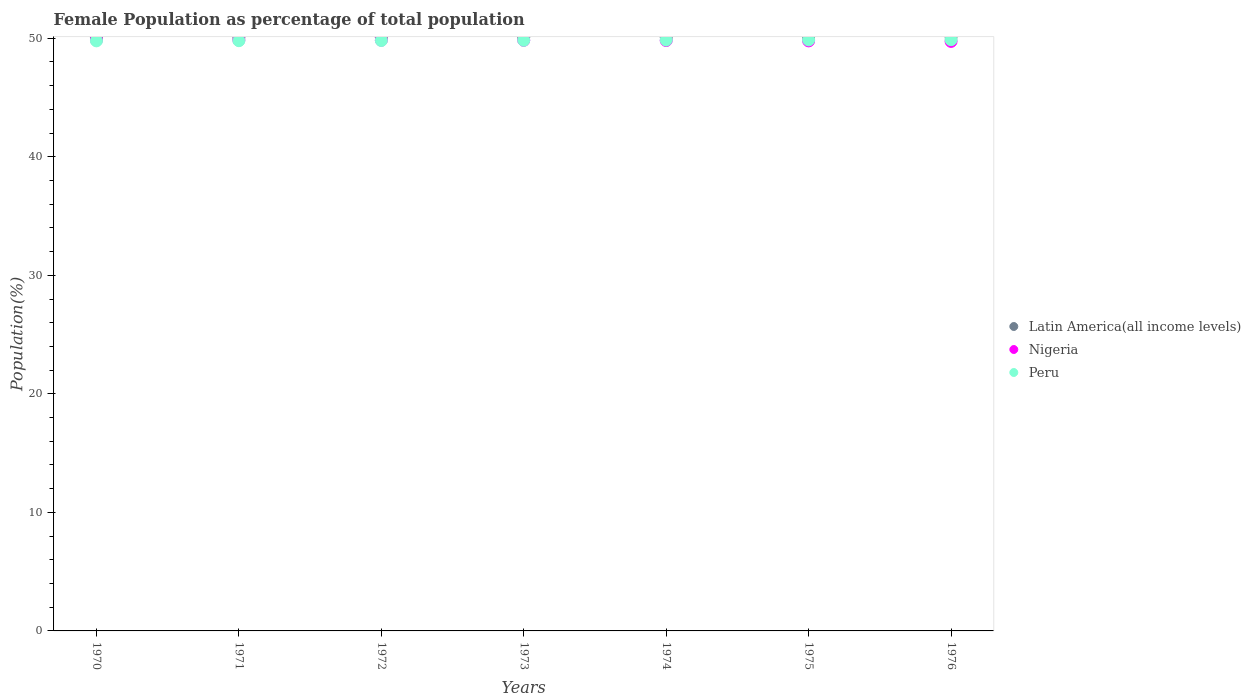How many different coloured dotlines are there?
Your response must be concise. 3. What is the female population in in Peru in 1972?
Make the answer very short. 49.81. Across all years, what is the maximum female population in in Nigeria?
Make the answer very short. 49.86. Across all years, what is the minimum female population in in Nigeria?
Your response must be concise. 49.73. In which year was the female population in in Peru maximum?
Your answer should be compact. 1976. In which year was the female population in in Nigeria minimum?
Offer a very short reply. 1976. What is the total female population in in Latin America(all income levels) in the graph?
Give a very brief answer. 350.6. What is the difference between the female population in in Peru in 1970 and that in 1973?
Your answer should be compact. -0.05. What is the difference between the female population in in Latin America(all income levels) in 1975 and the female population in in Peru in 1976?
Offer a terse response. 0.23. What is the average female population in in Peru per year?
Ensure brevity in your answer.  49.83. In the year 1970, what is the difference between the female population in in Nigeria and female population in in Peru?
Provide a short and direct response. 0.08. What is the ratio of the female population in in Nigeria in 1974 to that in 1976?
Offer a very short reply. 1. Is the difference between the female population in in Nigeria in 1971 and 1975 greater than the difference between the female population in in Peru in 1971 and 1975?
Your response must be concise. Yes. What is the difference between the highest and the second highest female population in in Peru?
Give a very brief answer. 0.02. What is the difference between the highest and the lowest female population in in Latin America(all income levels)?
Offer a very short reply. 0.06. In how many years, is the female population in in Latin America(all income levels) greater than the average female population in in Latin America(all income levels) taken over all years?
Give a very brief answer. 3. Is the sum of the female population in in Nigeria in 1970 and 1973 greater than the maximum female population in in Peru across all years?
Make the answer very short. Yes. Is it the case that in every year, the sum of the female population in in Latin America(all income levels) and female population in in Nigeria  is greater than the female population in in Peru?
Provide a succinct answer. Yes. Does the female population in in Latin America(all income levels) monotonically increase over the years?
Ensure brevity in your answer.  Yes. Is the female population in in Peru strictly less than the female population in in Nigeria over the years?
Give a very brief answer. No. Are the values on the major ticks of Y-axis written in scientific E-notation?
Provide a succinct answer. No. Does the graph contain any zero values?
Your answer should be compact. No. Where does the legend appear in the graph?
Ensure brevity in your answer.  Center right. What is the title of the graph?
Your response must be concise. Female Population as percentage of total population. What is the label or title of the X-axis?
Your response must be concise. Years. What is the label or title of the Y-axis?
Your answer should be very brief. Population(%). What is the Population(%) in Latin America(all income levels) in 1970?
Your answer should be very brief. 50.06. What is the Population(%) in Nigeria in 1970?
Your answer should be very brief. 49.86. What is the Population(%) in Peru in 1970?
Your answer should be very brief. 49.78. What is the Population(%) of Latin America(all income levels) in 1971?
Offer a terse response. 50.06. What is the Population(%) in Nigeria in 1971?
Provide a short and direct response. 49.85. What is the Population(%) in Peru in 1971?
Your answer should be very brief. 49.79. What is the Population(%) of Latin America(all income levels) in 1972?
Ensure brevity in your answer.  50.07. What is the Population(%) in Nigeria in 1972?
Offer a very short reply. 49.84. What is the Population(%) in Peru in 1972?
Make the answer very short. 49.81. What is the Population(%) in Latin America(all income levels) in 1973?
Your answer should be very brief. 50.08. What is the Population(%) of Nigeria in 1973?
Ensure brevity in your answer.  49.83. What is the Population(%) of Peru in 1973?
Ensure brevity in your answer.  49.83. What is the Population(%) of Latin America(all income levels) in 1974?
Keep it short and to the point. 50.09. What is the Population(%) of Nigeria in 1974?
Provide a short and direct response. 49.81. What is the Population(%) in Peru in 1974?
Offer a very short reply. 49.84. What is the Population(%) in Latin America(all income levels) in 1975?
Your answer should be compact. 50.11. What is the Population(%) of Nigeria in 1975?
Provide a succinct answer. 49.78. What is the Population(%) in Peru in 1975?
Offer a very short reply. 49.86. What is the Population(%) of Latin America(all income levels) in 1976?
Offer a very short reply. 50.12. What is the Population(%) in Nigeria in 1976?
Give a very brief answer. 49.73. What is the Population(%) of Peru in 1976?
Give a very brief answer. 49.88. Across all years, what is the maximum Population(%) of Latin America(all income levels)?
Your response must be concise. 50.12. Across all years, what is the maximum Population(%) in Nigeria?
Keep it short and to the point. 49.86. Across all years, what is the maximum Population(%) in Peru?
Your answer should be compact. 49.88. Across all years, what is the minimum Population(%) in Latin America(all income levels)?
Your response must be concise. 50.06. Across all years, what is the minimum Population(%) of Nigeria?
Your answer should be compact. 49.73. Across all years, what is the minimum Population(%) in Peru?
Your response must be concise. 49.78. What is the total Population(%) of Latin America(all income levels) in the graph?
Provide a short and direct response. 350.6. What is the total Population(%) of Nigeria in the graph?
Offer a very short reply. 348.69. What is the total Population(%) of Peru in the graph?
Offer a very short reply. 348.79. What is the difference between the Population(%) of Latin America(all income levels) in 1970 and that in 1971?
Your response must be concise. -0.01. What is the difference between the Population(%) in Nigeria in 1970 and that in 1971?
Offer a very short reply. 0.01. What is the difference between the Population(%) in Peru in 1970 and that in 1971?
Your answer should be very brief. -0.01. What is the difference between the Population(%) in Latin America(all income levels) in 1970 and that in 1972?
Your response must be concise. -0.02. What is the difference between the Population(%) in Nigeria in 1970 and that in 1972?
Make the answer very short. 0.02. What is the difference between the Population(%) of Peru in 1970 and that in 1972?
Make the answer very short. -0.03. What is the difference between the Population(%) of Latin America(all income levels) in 1970 and that in 1973?
Your answer should be compact. -0.03. What is the difference between the Population(%) in Nigeria in 1970 and that in 1973?
Your response must be concise. 0.03. What is the difference between the Population(%) of Peru in 1970 and that in 1973?
Your response must be concise. -0.05. What is the difference between the Population(%) of Latin America(all income levels) in 1970 and that in 1974?
Offer a terse response. -0.04. What is the difference between the Population(%) in Nigeria in 1970 and that in 1974?
Give a very brief answer. 0.05. What is the difference between the Population(%) in Peru in 1970 and that in 1974?
Offer a very short reply. -0.06. What is the difference between the Population(%) in Latin America(all income levels) in 1970 and that in 1975?
Your answer should be very brief. -0.05. What is the difference between the Population(%) in Nigeria in 1970 and that in 1975?
Provide a short and direct response. 0.08. What is the difference between the Population(%) of Peru in 1970 and that in 1975?
Your answer should be compact. -0.08. What is the difference between the Population(%) of Latin America(all income levels) in 1970 and that in 1976?
Offer a terse response. -0.06. What is the difference between the Population(%) in Nigeria in 1970 and that in 1976?
Your answer should be very brief. 0.13. What is the difference between the Population(%) of Peru in 1970 and that in 1976?
Provide a short and direct response. -0.1. What is the difference between the Population(%) of Latin America(all income levels) in 1971 and that in 1972?
Offer a very short reply. -0.01. What is the difference between the Population(%) in Nigeria in 1971 and that in 1972?
Offer a terse response. 0.01. What is the difference between the Population(%) in Peru in 1971 and that in 1972?
Your response must be concise. -0.02. What is the difference between the Population(%) of Latin America(all income levels) in 1971 and that in 1973?
Give a very brief answer. -0.02. What is the difference between the Population(%) of Nigeria in 1971 and that in 1973?
Offer a terse response. 0.02. What is the difference between the Population(%) in Peru in 1971 and that in 1973?
Provide a short and direct response. -0.03. What is the difference between the Population(%) of Latin America(all income levels) in 1971 and that in 1974?
Provide a short and direct response. -0.03. What is the difference between the Population(%) in Nigeria in 1971 and that in 1974?
Your answer should be very brief. 0.04. What is the difference between the Population(%) in Peru in 1971 and that in 1974?
Give a very brief answer. -0.05. What is the difference between the Population(%) in Latin America(all income levels) in 1971 and that in 1975?
Provide a succinct answer. -0.04. What is the difference between the Population(%) in Nigeria in 1971 and that in 1975?
Provide a succinct answer. 0.07. What is the difference between the Population(%) of Peru in 1971 and that in 1975?
Your response must be concise. -0.07. What is the difference between the Population(%) in Latin America(all income levels) in 1971 and that in 1976?
Offer a terse response. -0.06. What is the difference between the Population(%) in Nigeria in 1971 and that in 1976?
Your answer should be very brief. 0.11. What is the difference between the Population(%) in Peru in 1971 and that in 1976?
Ensure brevity in your answer.  -0.08. What is the difference between the Population(%) of Latin America(all income levels) in 1972 and that in 1973?
Make the answer very short. -0.01. What is the difference between the Population(%) of Nigeria in 1972 and that in 1973?
Keep it short and to the point. 0.01. What is the difference between the Population(%) of Peru in 1972 and that in 1973?
Keep it short and to the point. -0.02. What is the difference between the Population(%) of Latin America(all income levels) in 1972 and that in 1974?
Make the answer very short. -0.02. What is the difference between the Population(%) of Nigeria in 1972 and that in 1974?
Keep it short and to the point. 0.03. What is the difference between the Population(%) in Peru in 1972 and that in 1974?
Ensure brevity in your answer.  -0.03. What is the difference between the Population(%) in Latin America(all income levels) in 1972 and that in 1975?
Provide a short and direct response. -0.03. What is the difference between the Population(%) of Nigeria in 1972 and that in 1975?
Offer a terse response. 0.06. What is the difference between the Population(%) in Peru in 1972 and that in 1975?
Give a very brief answer. -0.05. What is the difference between the Population(%) in Latin America(all income levels) in 1972 and that in 1976?
Offer a very short reply. -0.05. What is the difference between the Population(%) in Nigeria in 1972 and that in 1976?
Your answer should be very brief. 0.1. What is the difference between the Population(%) of Peru in 1972 and that in 1976?
Make the answer very short. -0.07. What is the difference between the Population(%) in Latin America(all income levels) in 1973 and that in 1974?
Offer a terse response. -0.01. What is the difference between the Population(%) of Nigeria in 1973 and that in 1974?
Your answer should be compact. 0.02. What is the difference between the Population(%) of Peru in 1973 and that in 1974?
Provide a short and direct response. -0.02. What is the difference between the Population(%) in Latin America(all income levels) in 1973 and that in 1975?
Your answer should be compact. -0.02. What is the difference between the Population(%) in Nigeria in 1973 and that in 1975?
Your response must be concise. 0.05. What is the difference between the Population(%) in Peru in 1973 and that in 1975?
Provide a short and direct response. -0.03. What is the difference between the Population(%) of Latin America(all income levels) in 1973 and that in 1976?
Provide a succinct answer. -0.04. What is the difference between the Population(%) in Nigeria in 1973 and that in 1976?
Make the answer very short. 0.09. What is the difference between the Population(%) in Peru in 1973 and that in 1976?
Offer a terse response. -0.05. What is the difference between the Population(%) in Latin America(all income levels) in 1974 and that in 1975?
Keep it short and to the point. -0.01. What is the difference between the Population(%) of Nigeria in 1974 and that in 1975?
Your response must be concise. 0.03. What is the difference between the Population(%) of Peru in 1974 and that in 1975?
Ensure brevity in your answer.  -0.02. What is the difference between the Population(%) in Latin America(all income levels) in 1974 and that in 1976?
Provide a succinct answer. -0.03. What is the difference between the Population(%) of Nigeria in 1974 and that in 1976?
Keep it short and to the point. 0.07. What is the difference between the Population(%) in Peru in 1974 and that in 1976?
Provide a succinct answer. -0.03. What is the difference between the Population(%) in Latin America(all income levels) in 1975 and that in 1976?
Your answer should be very brief. -0.01. What is the difference between the Population(%) in Nigeria in 1975 and that in 1976?
Provide a succinct answer. 0.04. What is the difference between the Population(%) in Peru in 1975 and that in 1976?
Your answer should be very brief. -0.02. What is the difference between the Population(%) of Latin America(all income levels) in 1970 and the Population(%) of Nigeria in 1971?
Your response must be concise. 0.21. What is the difference between the Population(%) in Latin America(all income levels) in 1970 and the Population(%) in Peru in 1971?
Ensure brevity in your answer.  0.26. What is the difference between the Population(%) in Nigeria in 1970 and the Population(%) in Peru in 1971?
Give a very brief answer. 0.07. What is the difference between the Population(%) in Latin America(all income levels) in 1970 and the Population(%) in Nigeria in 1972?
Provide a short and direct response. 0.22. What is the difference between the Population(%) in Latin America(all income levels) in 1970 and the Population(%) in Peru in 1972?
Ensure brevity in your answer.  0.25. What is the difference between the Population(%) in Nigeria in 1970 and the Population(%) in Peru in 1972?
Your answer should be compact. 0.05. What is the difference between the Population(%) in Latin America(all income levels) in 1970 and the Population(%) in Nigeria in 1973?
Offer a very short reply. 0.23. What is the difference between the Population(%) in Latin America(all income levels) in 1970 and the Population(%) in Peru in 1973?
Provide a short and direct response. 0.23. What is the difference between the Population(%) of Nigeria in 1970 and the Population(%) of Peru in 1973?
Provide a succinct answer. 0.04. What is the difference between the Population(%) in Latin America(all income levels) in 1970 and the Population(%) in Nigeria in 1974?
Offer a terse response. 0.25. What is the difference between the Population(%) in Latin America(all income levels) in 1970 and the Population(%) in Peru in 1974?
Offer a very short reply. 0.21. What is the difference between the Population(%) in Nigeria in 1970 and the Population(%) in Peru in 1974?
Make the answer very short. 0.02. What is the difference between the Population(%) in Latin America(all income levels) in 1970 and the Population(%) in Nigeria in 1975?
Give a very brief answer. 0.28. What is the difference between the Population(%) of Latin America(all income levels) in 1970 and the Population(%) of Peru in 1975?
Make the answer very short. 0.2. What is the difference between the Population(%) in Latin America(all income levels) in 1970 and the Population(%) in Nigeria in 1976?
Ensure brevity in your answer.  0.32. What is the difference between the Population(%) in Latin America(all income levels) in 1970 and the Population(%) in Peru in 1976?
Keep it short and to the point. 0.18. What is the difference between the Population(%) in Nigeria in 1970 and the Population(%) in Peru in 1976?
Keep it short and to the point. -0.02. What is the difference between the Population(%) of Latin America(all income levels) in 1971 and the Population(%) of Nigeria in 1972?
Offer a very short reply. 0.23. What is the difference between the Population(%) in Latin America(all income levels) in 1971 and the Population(%) in Peru in 1972?
Ensure brevity in your answer.  0.26. What is the difference between the Population(%) in Nigeria in 1971 and the Population(%) in Peru in 1972?
Ensure brevity in your answer.  0.04. What is the difference between the Population(%) of Latin America(all income levels) in 1971 and the Population(%) of Nigeria in 1973?
Ensure brevity in your answer.  0.24. What is the difference between the Population(%) in Latin America(all income levels) in 1971 and the Population(%) in Peru in 1973?
Give a very brief answer. 0.24. What is the difference between the Population(%) of Nigeria in 1971 and the Population(%) of Peru in 1973?
Offer a very short reply. 0.02. What is the difference between the Population(%) in Latin America(all income levels) in 1971 and the Population(%) in Nigeria in 1974?
Your response must be concise. 0.26. What is the difference between the Population(%) of Latin America(all income levels) in 1971 and the Population(%) of Peru in 1974?
Give a very brief answer. 0.22. What is the difference between the Population(%) of Nigeria in 1971 and the Population(%) of Peru in 1974?
Give a very brief answer. 0.01. What is the difference between the Population(%) of Latin America(all income levels) in 1971 and the Population(%) of Nigeria in 1975?
Give a very brief answer. 0.29. What is the difference between the Population(%) of Latin America(all income levels) in 1971 and the Population(%) of Peru in 1975?
Keep it short and to the point. 0.2. What is the difference between the Population(%) of Nigeria in 1971 and the Population(%) of Peru in 1975?
Keep it short and to the point. -0.01. What is the difference between the Population(%) in Latin America(all income levels) in 1971 and the Population(%) in Nigeria in 1976?
Keep it short and to the point. 0.33. What is the difference between the Population(%) in Latin America(all income levels) in 1971 and the Population(%) in Peru in 1976?
Give a very brief answer. 0.19. What is the difference between the Population(%) in Nigeria in 1971 and the Population(%) in Peru in 1976?
Keep it short and to the point. -0.03. What is the difference between the Population(%) of Latin America(all income levels) in 1972 and the Population(%) of Nigeria in 1973?
Provide a succinct answer. 0.25. What is the difference between the Population(%) of Latin America(all income levels) in 1972 and the Population(%) of Peru in 1973?
Offer a terse response. 0.25. What is the difference between the Population(%) in Nigeria in 1972 and the Population(%) in Peru in 1973?
Your answer should be compact. 0.01. What is the difference between the Population(%) in Latin America(all income levels) in 1972 and the Population(%) in Nigeria in 1974?
Your answer should be compact. 0.27. What is the difference between the Population(%) in Latin America(all income levels) in 1972 and the Population(%) in Peru in 1974?
Make the answer very short. 0.23. What is the difference between the Population(%) of Nigeria in 1972 and the Population(%) of Peru in 1974?
Provide a succinct answer. -0. What is the difference between the Population(%) in Latin America(all income levels) in 1972 and the Population(%) in Nigeria in 1975?
Your response must be concise. 0.3. What is the difference between the Population(%) in Latin America(all income levels) in 1972 and the Population(%) in Peru in 1975?
Provide a short and direct response. 0.21. What is the difference between the Population(%) in Nigeria in 1972 and the Population(%) in Peru in 1975?
Your answer should be compact. -0.02. What is the difference between the Population(%) in Latin America(all income levels) in 1972 and the Population(%) in Nigeria in 1976?
Keep it short and to the point. 0.34. What is the difference between the Population(%) of Latin America(all income levels) in 1972 and the Population(%) of Peru in 1976?
Give a very brief answer. 0.2. What is the difference between the Population(%) of Nigeria in 1972 and the Population(%) of Peru in 1976?
Keep it short and to the point. -0.04. What is the difference between the Population(%) in Latin America(all income levels) in 1973 and the Population(%) in Nigeria in 1974?
Make the answer very short. 0.28. What is the difference between the Population(%) of Latin America(all income levels) in 1973 and the Population(%) of Peru in 1974?
Your answer should be very brief. 0.24. What is the difference between the Population(%) in Nigeria in 1973 and the Population(%) in Peru in 1974?
Provide a short and direct response. -0.02. What is the difference between the Population(%) of Latin America(all income levels) in 1973 and the Population(%) of Nigeria in 1975?
Provide a short and direct response. 0.31. What is the difference between the Population(%) in Latin America(all income levels) in 1973 and the Population(%) in Peru in 1975?
Your response must be concise. 0.22. What is the difference between the Population(%) of Nigeria in 1973 and the Population(%) of Peru in 1975?
Provide a succinct answer. -0.03. What is the difference between the Population(%) in Latin America(all income levels) in 1973 and the Population(%) in Nigeria in 1976?
Keep it short and to the point. 0.35. What is the difference between the Population(%) of Latin America(all income levels) in 1973 and the Population(%) of Peru in 1976?
Provide a succinct answer. 0.21. What is the difference between the Population(%) in Nigeria in 1973 and the Population(%) in Peru in 1976?
Ensure brevity in your answer.  -0.05. What is the difference between the Population(%) in Latin America(all income levels) in 1974 and the Population(%) in Nigeria in 1975?
Your answer should be very brief. 0.32. What is the difference between the Population(%) in Latin America(all income levels) in 1974 and the Population(%) in Peru in 1975?
Ensure brevity in your answer.  0.23. What is the difference between the Population(%) in Nigeria in 1974 and the Population(%) in Peru in 1975?
Give a very brief answer. -0.05. What is the difference between the Population(%) in Latin America(all income levels) in 1974 and the Population(%) in Nigeria in 1976?
Provide a short and direct response. 0.36. What is the difference between the Population(%) of Latin America(all income levels) in 1974 and the Population(%) of Peru in 1976?
Offer a terse response. 0.22. What is the difference between the Population(%) in Nigeria in 1974 and the Population(%) in Peru in 1976?
Provide a succinct answer. -0.07. What is the difference between the Population(%) in Latin America(all income levels) in 1975 and the Population(%) in Nigeria in 1976?
Give a very brief answer. 0.37. What is the difference between the Population(%) in Latin America(all income levels) in 1975 and the Population(%) in Peru in 1976?
Offer a very short reply. 0.23. What is the difference between the Population(%) of Nigeria in 1975 and the Population(%) of Peru in 1976?
Ensure brevity in your answer.  -0.1. What is the average Population(%) in Latin America(all income levels) per year?
Provide a succinct answer. 50.09. What is the average Population(%) in Nigeria per year?
Your response must be concise. 49.81. What is the average Population(%) of Peru per year?
Give a very brief answer. 49.83. In the year 1970, what is the difference between the Population(%) of Latin America(all income levels) and Population(%) of Nigeria?
Your answer should be compact. 0.2. In the year 1970, what is the difference between the Population(%) of Latin America(all income levels) and Population(%) of Peru?
Your answer should be very brief. 0.28. In the year 1970, what is the difference between the Population(%) in Nigeria and Population(%) in Peru?
Give a very brief answer. 0.08. In the year 1971, what is the difference between the Population(%) of Latin America(all income levels) and Population(%) of Nigeria?
Your answer should be compact. 0.21. In the year 1971, what is the difference between the Population(%) in Latin America(all income levels) and Population(%) in Peru?
Provide a succinct answer. 0.27. In the year 1971, what is the difference between the Population(%) in Nigeria and Population(%) in Peru?
Your answer should be very brief. 0.06. In the year 1972, what is the difference between the Population(%) in Latin America(all income levels) and Population(%) in Nigeria?
Offer a very short reply. 0.23. In the year 1972, what is the difference between the Population(%) in Latin America(all income levels) and Population(%) in Peru?
Your answer should be very brief. 0.26. In the year 1972, what is the difference between the Population(%) in Nigeria and Population(%) in Peru?
Provide a succinct answer. 0.03. In the year 1973, what is the difference between the Population(%) of Latin America(all income levels) and Population(%) of Nigeria?
Keep it short and to the point. 0.26. In the year 1973, what is the difference between the Population(%) of Latin America(all income levels) and Population(%) of Peru?
Your answer should be very brief. 0.26. In the year 1974, what is the difference between the Population(%) of Latin America(all income levels) and Population(%) of Nigeria?
Make the answer very short. 0.29. In the year 1974, what is the difference between the Population(%) in Latin America(all income levels) and Population(%) in Peru?
Offer a very short reply. 0.25. In the year 1974, what is the difference between the Population(%) in Nigeria and Population(%) in Peru?
Ensure brevity in your answer.  -0.04. In the year 1975, what is the difference between the Population(%) of Latin America(all income levels) and Population(%) of Nigeria?
Provide a short and direct response. 0.33. In the year 1975, what is the difference between the Population(%) of Latin America(all income levels) and Population(%) of Peru?
Offer a terse response. 0.25. In the year 1975, what is the difference between the Population(%) in Nigeria and Population(%) in Peru?
Your response must be concise. -0.08. In the year 1976, what is the difference between the Population(%) of Latin America(all income levels) and Population(%) of Nigeria?
Your answer should be very brief. 0.39. In the year 1976, what is the difference between the Population(%) in Latin America(all income levels) and Population(%) in Peru?
Offer a terse response. 0.24. In the year 1976, what is the difference between the Population(%) of Nigeria and Population(%) of Peru?
Ensure brevity in your answer.  -0.14. What is the ratio of the Population(%) in Latin America(all income levels) in 1970 to that in 1971?
Offer a terse response. 1. What is the ratio of the Population(%) in Peru in 1970 to that in 1971?
Your answer should be very brief. 1. What is the ratio of the Population(%) of Peru in 1970 to that in 1972?
Provide a short and direct response. 1. What is the ratio of the Population(%) of Latin America(all income levels) in 1970 to that in 1973?
Your answer should be very brief. 1. What is the ratio of the Population(%) in Peru in 1970 to that in 1973?
Your response must be concise. 1. What is the ratio of the Population(%) of Latin America(all income levels) in 1970 to that in 1974?
Provide a short and direct response. 1. What is the ratio of the Population(%) of Nigeria in 1970 to that in 1974?
Offer a very short reply. 1. What is the ratio of the Population(%) in Peru in 1970 to that in 1975?
Offer a very short reply. 1. What is the ratio of the Population(%) in Latin America(all income levels) in 1970 to that in 1976?
Keep it short and to the point. 1. What is the ratio of the Population(%) of Peru in 1970 to that in 1976?
Your answer should be compact. 1. What is the ratio of the Population(%) of Nigeria in 1971 to that in 1972?
Your answer should be very brief. 1. What is the ratio of the Population(%) of Peru in 1971 to that in 1972?
Keep it short and to the point. 1. What is the ratio of the Population(%) of Latin America(all income levels) in 1971 to that in 1973?
Provide a short and direct response. 1. What is the ratio of the Population(%) in Nigeria in 1971 to that in 1973?
Your answer should be compact. 1. What is the ratio of the Population(%) of Latin America(all income levels) in 1971 to that in 1974?
Your answer should be compact. 1. What is the ratio of the Population(%) in Nigeria in 1971 to that in 1974?
Provide a succinct answer. 1. What is the ratio of the Population(%) of Peru in 1971 to that in 1974?
Ensure brevity in your answer.  1. What is the ratio of the Population(%) in Nigeria in 1971 to that in 1975?
Your answer should be very brief. 1. What is the ratio of the Population(%) in Peru in 1971 to that in 1976?
Make the answer very short. 1. What is the ratio of the Population(%) of Latin America(all income levels) in 1972 to that in 1973?
Provide a short and direct response. 1. What is the ratio of the Population(%) in Nigeria in 1972 to that in 1973?
Provide a short and direct response. 1. What is the ratio of the Population(%) of Latin America(all income levels) in 1972 to that in 1974?
Keep it short and to the point. 1. What is the ratio of the Population(%) of Nigeria in 1972 to that in 1974?
Provide a short and direct response. 1. What is the ratio of the Population(%) in Peru in 1972 to that in 1974?
Your answer should be very brief. 1. What is the ratio of the Population(%) in Latin America(all income levels) in 1972 to that in 1975?
Your response must be concise. 1. What is the ratio of the Population(%) in Nigeria in 1972 to that in 1975?
Make the answer very short. 1. What is the ratio of the Population(%) of Peru in 1972 to that in 1975?
Provide a succinct answer. 1. What is the ratio of the Population(%) of Latin America(all income levels) in 1973 to that in 1974?
Your answer should be very brief. 1. What is the ratio of the Population(%) of Nigeria in 1973 to that in 1974?
Ensure brevity in your answer.  1. What is the ratio of the Population(%) of Nigeria in 1973 to that in 1975?
Ensure brevity in your answer.  1. What is the ratio of the Population(%) in Latin America(all income levels) in 1974 to that in 1975?
Ensure brevity in your answer.  1. What is the ratio of the Population(%) in Nigeria in 1974 to that in 1975?
Your answer should be compact. 1. What is the ratio of the Population(%) in Nigeria in 1974 to that in 1976?
Offer a terse response. 1. What is the ratio of the Population(%) of Peru in 1975 to that in 1976?
Make the answer very short. 1. What is the difference between the highest and the second highest Population(%) in Latin America(all income levels)?
Offer a terse response. 0.01. What is the difference between the highest and the second highest Population(%) of Nigeria?
Provide a short and direct response. 0.01. What is the difference between the highest and the second highest Population(%) in Peru?
Offer a very short reply. 0.02. What is the difference between the highest and the lowest Population(%) of Latin America(all income levels)?
Offer a terse response. 0.06. What is the difference between the highest and the lowest Population(%) of Nigeria?
Your answer should be compact. 0.13. What is the difference between the highest and the lowest Population(%) in Peru?
Offer a terse response. 0.1. 